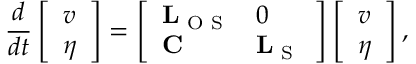Convert formula to latex. <formula><loc_0><loc_0><loc_500><loc_500>\frac { d } { d t } \left [ \begin{array} { l } { v } \\ { \eta } \end{array} \right ] = \left [ \begin{array} { l l } { L _ { O S } } & { 0 } \\ { C } & { L _ { S } } \end{array} \right ] \left [ \begin{array} { l } { v } \\ { \eta } \end{array} \right ] ,</formula> 